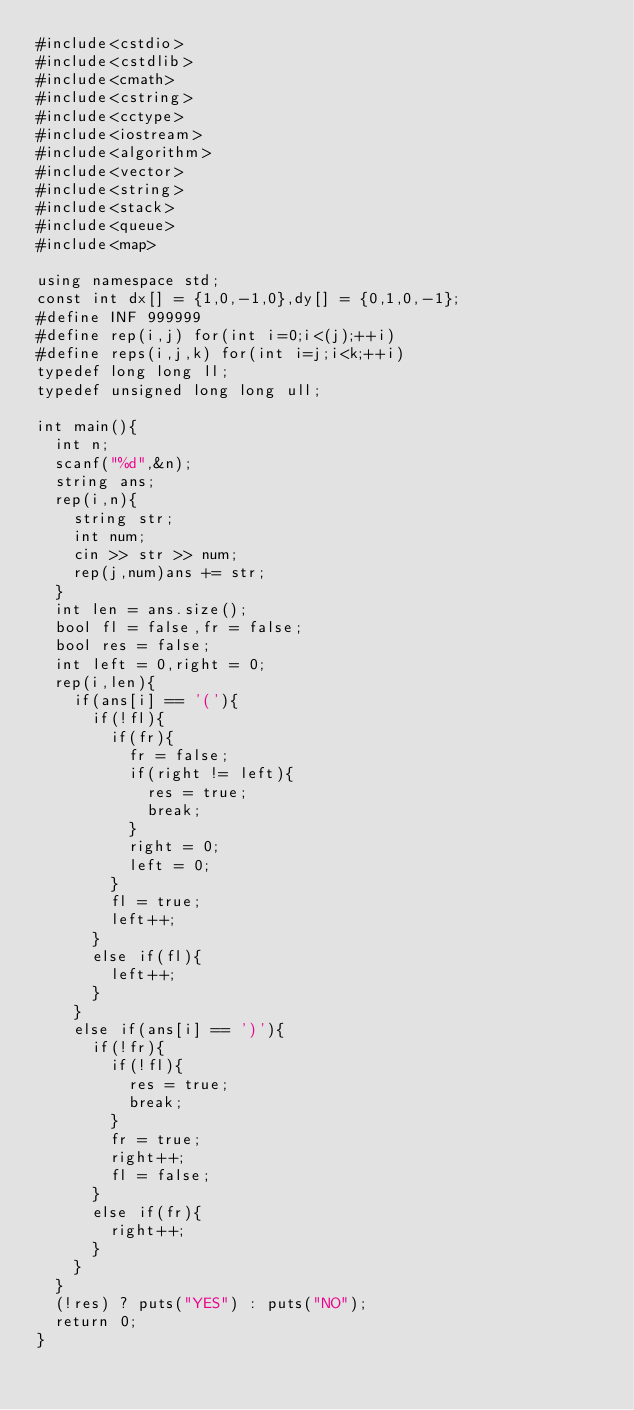Convert code to text. <code><loc_0><loc_0><loc_500><loc_500><_C++_>#include<cstdio>
#include<cstdlib>
#include<cmath>
#include<cstring>
#include<cctype>
#include<iostream>
#include<algorithm>
#include<vector>
#include<string>
#include<stack>
#include<queue>
#include<map>

using namespace std;
const int dx[] = {1,0,-1,0},dy[] = {0,1,0,-1};
#define INF 999999
#define rep(i,j) for(int i=0;i<(j);++i)
#define reps(i,j,k) for(int i=j;i<k;++i)
typedef long long ll;
typedef unsigned long long ull;

int main(){
	int n;
	scanf("%d",&n);
	string ans;
	rep(i,n){
		string str;
		int num;
		cin >> str >> num;
		rep(j,num)ans += str;
	}
	int len = ans.size();
	bool fl = false,fr = false;
	bool res = false;
	int left = 0,right = 0;
	rep(i,len){
		if(ans[i] == '('){
			if(!fl){
				if(fr){
					fr = false;
					if(right != left){
						res = true;
						break;
					}
					right = 0;
					left = 0;
				}
				fl = true;
				left++;
			}
			else if(fl){
				left++;
			}
		}
		else if(ans[i] == ')'){
			if(!fr){
				if(!fl){
					res = true;
					break;
				}
				fr = true;
				right++;
				fl = false;
			}
			else if(fr){
				right++;
			}
		}
	}
	(!res) ? puts("YES") : puts("NO");
	return 0;
}</code> 